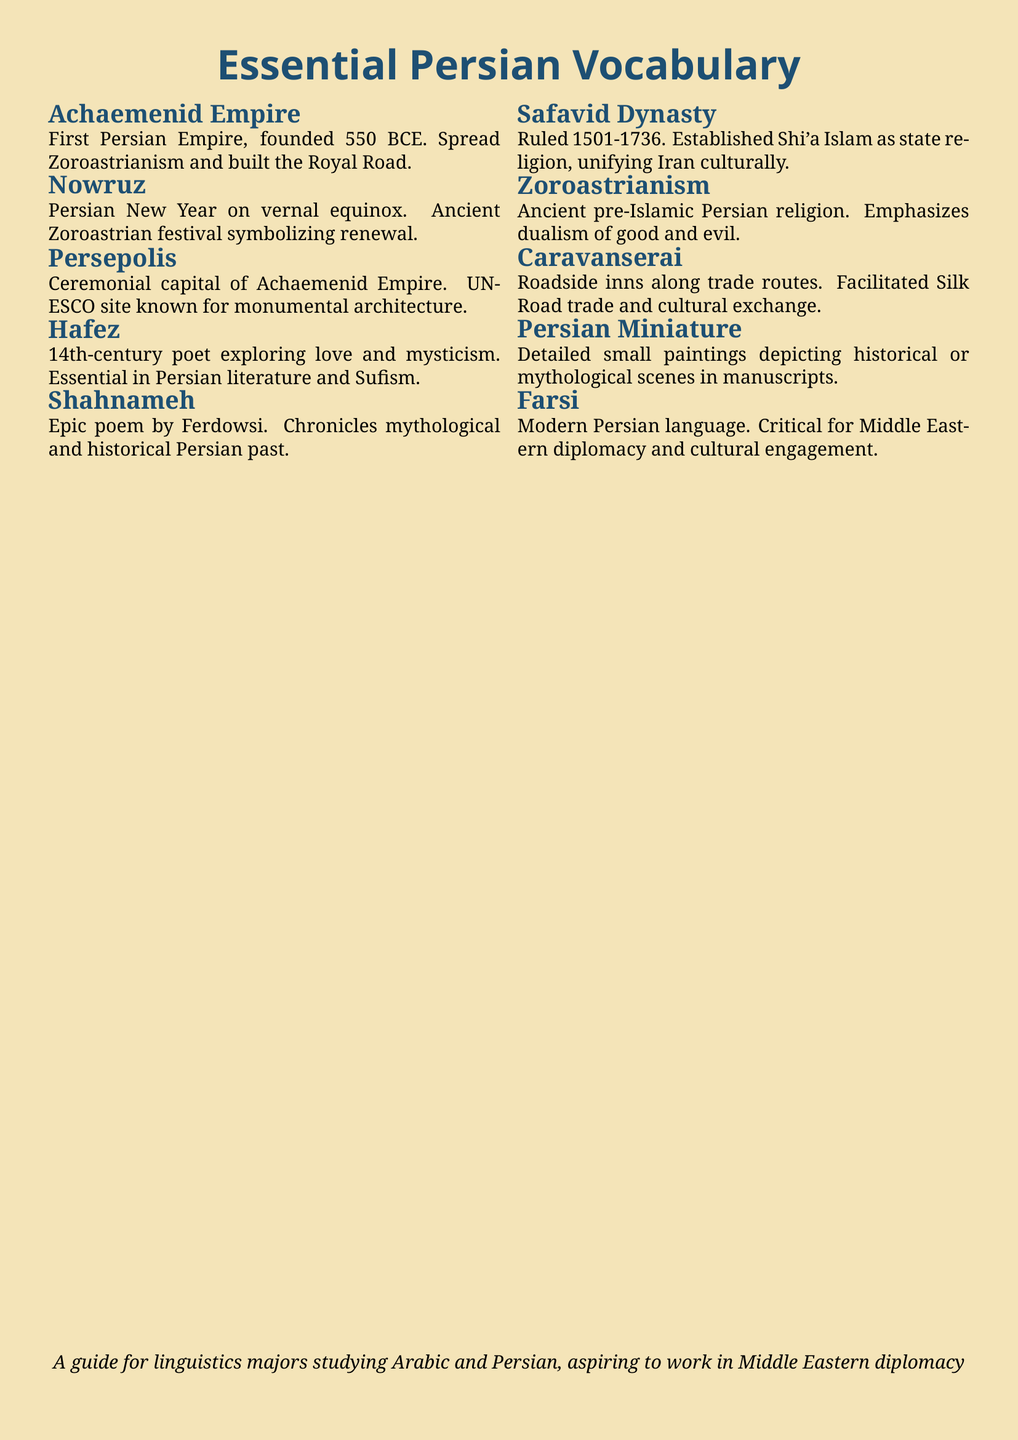What event does Nowruz celebrate? Nowruz is the Persian New Year celebrated on the vernal equinox, symbolizing renewal.
Answer: renewal What is the name of the epic poem by Ferdowsi? The epic poem chronicling Persian history is known as Shahnameh.
Answer: Shahnameh Which empire is associated with Zoroastrianism? The Achaemenid Empire is the first Persian Empire that spread Zoroastrianism.
Answer: Achaemenid Empire What did the Safavid Dynasty establish as the state religion? The Safavid Dynasty established Shi'a Islam as the state religion.
Answer: Shi'a Islam What are caravanserais used for? Caravanserais are roadside inns that facilitated trade and cultural exchange on routes like the Silk Road.
Answer: inns Who is recognized for exploring love and mysticism in Persian poetry? Hafez is the 14th-century poet known for his exploration of love and mysticism.
Answer: Hafez What type of art is depicted in Persian Miniature? Persian Miniature refers to detailed small paintings depicting historical or mythological scenes.
Answer: small paintings In what historical period did the Safavid Dynasty rule? The Safavid Dynasty ruled from 1501 to 1736.
Answer: 1501-1736 